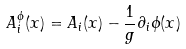Convert formula to latex. <formula><loc_0><loc_0><loc_500><loc_500>A _ { i } ^ { \phi } ( x ) = A _ { i } ( x ) - \frac { 1 } { g } \partial _ { i } \phi ( x )</formula> 